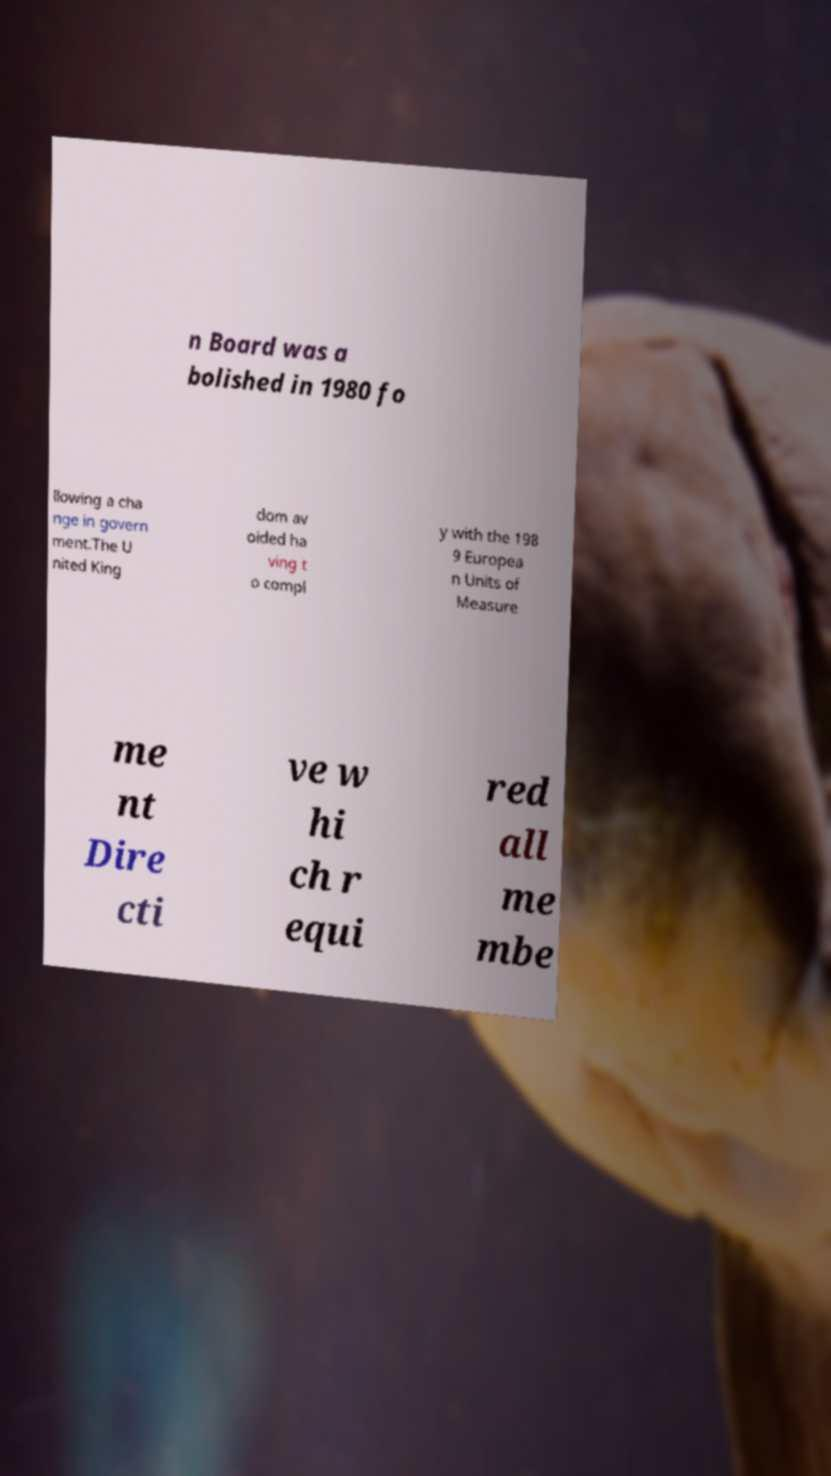Can you read and provide the text displayed in the image?This photo seems to have some interesting text. Can you extract and type it out for me? n Board was a bolished in 1980 fo llowing a cha nge in govern ment.The U nited King dom av oided ha ving t o compl y with the 198 9 Europea n Units of Measure me nt Dire cti ve w hi ch r equi red all me mbe 